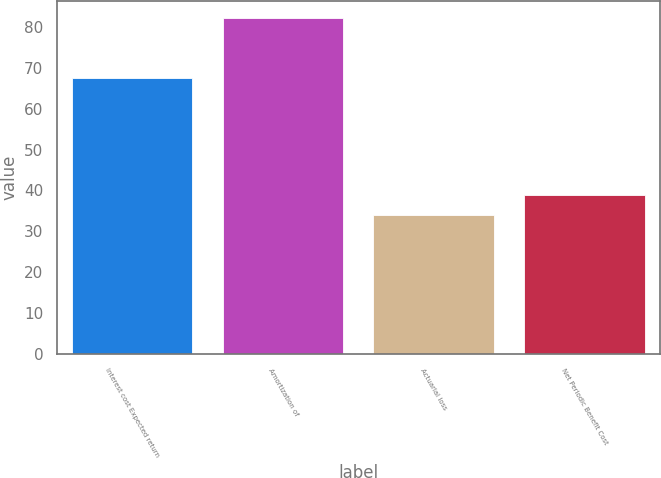Convert chart. <chart><loc_0><loc_0><loc_500><loc_500><bar_chart><fcel>Interest cost Expected return<fcel>Amortization of<fcel>Actuarial loss<fcel>Net Periodic Benefit Cost<nl><fcel>67.6<fcel>82.1<fcel>34<fcel>38.81<nl></chart> 